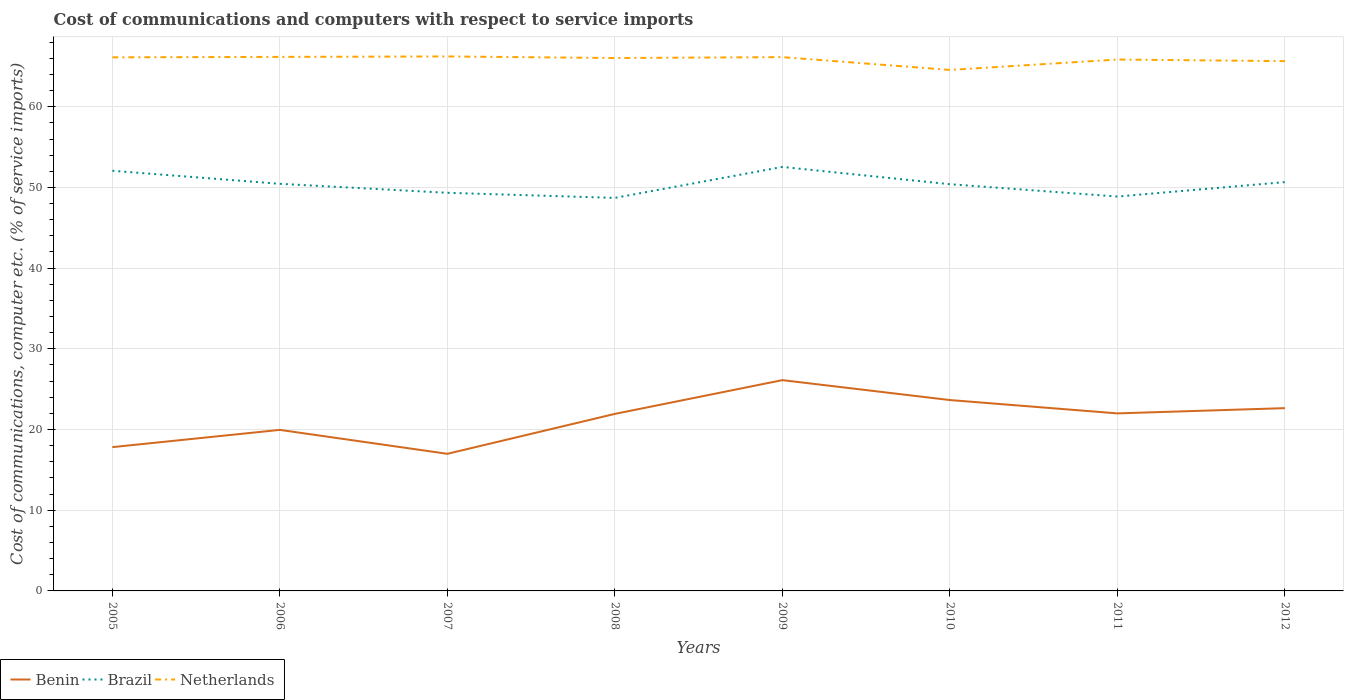Does the line corresponding to Brazil intersect with the line corresponding to Netherlands?
Offer a terse response. No. Is the number of lines equal to the number of legend labels?
Provide a succinct answer. Yes. Across all years, what is the maximum cost of communications and computers in Brazil?
Your response must be concise. 48.7. In which year was the cost of communications and computers in Netherlands maximum?
Keep it short and to the point. 2010. What is the total cost of communications and computers in Netherlands in the graph?
Give a very brief answer. 0.19. What is the difference between the highest and the second highest cost of communications and computers in Netherlands?
Keep it short and to the point. 1.67. How many lines are there?
Offer a very short reply. 3. How many years are there in the graph?
Offer a very short reply. 8. What is the difference between two consecutive major ticks on the Y-axis?
Offer a very short reply. 10. Where does the legend appear in the graph?
Offer a terse response. Bottom left. How many legend labels are there?
Your answer should be very brief. 3. How are the legend labels stacked?
Provide a succinct answer. Horizontal. What is the title of the graph?
Your answer should be very brief. Cost of communications and computers with respect to service imports. Does "Euro area" appear as one of the legend labels in the graph?
Provide a short and direct response. No. What is the label or title of the Y-axis?
Ensure brevity in your answer.  Cost of communications, computer etc. (% of service imports). What is the Cost of communications, computer etc. (% of service imports) in Benin in 2005?
Provide a short and direct response. 17.82. What is the Cost of communications, computer etc. (% of service imports) of Brazil in 2005?
Ensure brevity in your answer.  52.06. What is the Cost of communications, computer etc. (% of service imports) of Netherlands in 2005?
Give a very brief answer. 66.12. What is the Cost of communications, computer etc. (% of service imports) in Benin in 2006?
Make the answer very short. 19.96. What is the Cost of communications, computer etc. (% of service imports) in Brazil in 2006?
Offer a very short reply. 50.45. What is the Cost of communications, computer etc. (% of service imports) of Netherlands in 2006?
Provide a short and direct response. 66.18. What is the Cost of communications, computer etc. (% of service imports) of Benin in 2007?
Give a very brief answer. 16.99. What is the Cost of communications, computer etc. (% of service imports) in Brazil in 2007?
Ensure brevity in your answer.  49.34. What is the Cost of communications, computer etc. (% of service imports) in Netherlands in 2007?
Give a very brief answer. 66.23. What is the Cost of communications, computer etc. (% of service imports) of Benin in 2008?
Offer a terse response. 21.94. What is the Cost of communications, computer etc. (% of service imports) of Brazil in 2008?
Your response must be concise. 48.7. What is the Cost of communications, computer etc. (% of service imports) of Netherlands in 2008?
Offer a terse response. 66.04. What is the Cost of communications, computer etc. (% of service imports) in Benin in 2009?
Your answer should be very brief. 26.12. What is the Cost of communications, computer etc. (% of service imports) of Brazil in 2009?
Your answer should be very brief. 52.54. What is the Cost of communications, computer etc. (% of service imports) of Netherlands in 2009?
Your answer should be compact. 66.15. What is the Cost of communications, computer etc. (% of service imports) of Benin in 2010?
Provide a succinct answer. 23.65. What is the Cost of communications, computer etc. (% of service imports) in Brazil in 2010?
Offer a terse response. 50.4. What is the Cost of communications, computer etc. (% of service imports) of Netherlands in 2010?
Offer a terse response. 64.56. What is the Cost of communications, computer etc. (% of service imports) of Benin in 2011?
Your response must be concise. 22. What is the Cost of communications, computer etc. (% of service imports) of Brazil in 2011?
Your response must be concise. 48.87. What is the Cost of communications, computer etc. (% of service imports) in Netherlands in 2011?
Your response must be concise. 65.85. What is the Cost of communications, computer etc. (% of service imports) of Benin in 2012?
Offer a terse response. 22.65. What is the Cost of communications, computer etc. (% of service imports) in Brazil in 2012?
Your response must be concise. 50.66. What is the Cost of communications, computer etc. (% of service imports) of Netherlands in 2012?
Ensure brevity in your answer.  65.65. Across all years, what is the maximum Cost of communications, computer etc. (% of service imports) in Benin?
Keep it short and to the point. 26.12. Across all years, what is the maximum Cost of communications, computer etc. (% of service imports) in Brazil?
Your response must be concise. 52.54. Across all years, what is the maximum Cost of communications, computer etc. (% of service imports) in Netherlands?
Ensure brevity in your answer.  66.23. Across all years, what is the minimum Cost of communications, computer etc. (% of service imports) in Benin?
Offer a terse response. 16.99. Across all years, what is the minimum Cost of communications, computer etc. (% of service imports) of Brazil?
Offer a terse response. 48.7. Across all years, what is the minimum Cost of communications, computer etc. (% of service imports) of Netherlands?
Your response must be concise. 64.56. What is the total Cost of communications, computer etc. (% of service imports) in Benin in the graph?
Make the answer very short. 171.12. What is the total Cost of communications, computer etc. (% of service imports) in Brazil in the graph?
Your response must be concise. 403.03. What is the total Cost of communications, computer etc. (% of service imports) of Netherlands in the graph?
Provide a short and direct response. 526.77. What is the difference between the Cost of communications, computer etc. (% of service imports) in Benin in 2005 and that in 2006?
Make the answer very short. -2.14. What is the difference between the Cost of communications, computer etc. (% of service imports) in Brazil in 2005 and that in 2006?
Offer a terse response. 1.61. What is the difference between the Cost of communications, computer etc. (% of service imports) of Netherlands in 2005 and that in 2006?
Offer a very short reply. -0.05. What is the difference between the Cost of communications, computer etc. (% of service imports) of Benin in 2005 and that in 2007?
Provide a short and direct response. 0.83. What is the difference between the Cost of communications, computer etc. (% of service imports) of Brazil in 2005 and that in 2007?
Provide a succinct answer. 2.73. What is the difference between the Cost of communications, computer etc. (% of service imports) in Netherlands in 2005 and that in 2007?
Provide a succinct answer. -0.11. What is the difference between the Cost of communications, computer etc. (% of service imports) in Benin in 2005 and that in 2008?
Your answer should be compact. -4.12. What is the difference between the Cost of communications, computer etc. (% of service imports) in Brazil in 2005 and that in 2008?
Offer a very short reply. 3.36. What is the difference between the Cost of communications, computer etc. (% of service imports) of Netherlands in 2005 and that in 2008?
Offer a terse response. 0.08. What is the difference between the Cost of communications, computer etc. (% of service imports) of Benin in 2005 and that in 2009?
Offer a terse response. -8.3. What is the difference between the Cost of communications, computer etc. (% of service imports) in Brazil in 2005 and that in 2009?
Your answer should be compact. -0.48. What is the difference between the Cost of communications, computer etc. (% of service imports) of Netherlands in 2005 and that in 2009?
Make the answer very short. -0.03. What is the difference between the Cost of communications, computer etc. (% of service imports) of Benin in 2005 and that in 2010?
Your response must be concise. -5.84. What is the difference between the Cost of communications, computer etc. (% of service imports) of Brazil in 2005 and that in 2010?
Your answer should be compact. 1.66. What is the difference between the Cost of communications, computer etc. (% of service imports) in Netherlands in 2005 and that in 2010?
Your answer should be very brief. 1.56. What is the difference between the Cost of communications, computer etc. (% of service imports) of Benin in 2005 and that in 2011?
Make the answer very short. -4.18. What is the difference between the Cost of communications, computer etc. (% of service imports) of Brazil in 2005 and that in 2011?
Your answer should be compact. 3.19. What is the difference between the Cost of communications, computer etc. (% of service imports) in Netherlands in 2005 and that in 2011?
Offer a very short reply. 0.27. What is the difference between the Cost of communications, computer etc. (% of service imports) of Benin in 2005 and that in 2012?
Your response must be concise. -4.83. What is the difference between the Cost of communications, computer etc. (% of service imports) of Brazil in 2005 and that in 2012?
Offer a terse response. 1.4. What is the difference between the Cost of communications, computer etc. (% of service imports) of Netherlands in 2005 and that in 2012?
Make the answer very short. 0.47. What is the difference between the Cost of communications, computer etc. (% of service imports) of Benin in 2006 and that in 2007?
Make the answer very short. 2.97. What is the difference between the Cost of communications, computer etc. (% of service imports) of Brazil in 2006 and that in 2007?
Your answer should be compact. 1.11. What is the difference between the Cost of communications, computer etc. (% of service imports) of Netherlands in 2006 and that in 2007?
Make the answer very short. -0.06. What is the difference between the Cost of communications, computer etc. (% of service imports) in Benin in 2006 and that in 2008?
Offer a very short reply. -1.98. What is the difference between the Cost of communications, computer etc. (% of service imports) in Brazil in 2006 and that in 2008?
Your answer should be compact. 1.75. What is the difference between the Cost of communications, computer etc. (% of service imports) of Netherlands in 2006 and that in 2008?
Offer a terse response. 0.14. What is the difference between the Cost of communications, computer etc. (% of service imports) of Benin in 2006 and that in 2009?
Provide a succinct answer. -6.17. What is the difference between the Cost of communications, computer etc. (% of service imports) of Brazil in 2006 and that in 2009?
Offer a very short reply. -2.09. What is the difference between the Cost of communications, computer etc. (% of service imports) in Netherlands in 2006 and that in 2009?
Ensure brevity in your answer.  0.03. What is the difference between the Cost of communications, computer etc. (% of service imports) of Benin in 2006 and that in 2010?
Your answer should be compact. -3.7. What is the difference between the Cost of communications, computer etc. (% of service imports) in Brazil in 2006 and that in 2010?
Offer a very short reply. 0.05. What is the difference between the Cost of communications, computer etc. (% of service imports) in Netherlands in 2006 and that in 2010?
Keep it short and to the point. 1.62. What is the difference between the Cost of communications, computer etc. (% of service imports) of Benin in 2006 and that in 2011?
Your answer should be compact. -2.04. What is the difference between the Cost of communications, computer etc. (% of service imports) of Brazil in 2006 and that in 2011?
Offer a very short reply. 1.58. What is the difference between the Cost of communications, computer etc. (% of service imports) in Netherlands in 2006 and that in 2011?
Your response must be concise. 0.33. What is the difference between the Cost of communications, computer etc. (% of service imports) of Benin in 2006 and that in 2012?
Your response must be concise. -2.7. What is the difference between the Cost of communications, computer etc. (% of service imports) in Brazil in 2006 and that in 2012?
Offer a terse response. -0.21. What is the difference between the Cost of communications, computer etc. (% of service imports) of Netherlands in 2006 and that in 2012?
Your answer should be very brief. 0.53. What is the difference between the Cost of communications, computer etc. (% of service imports) in Benin in 2007 and that in 2008?
Provide a succinct answer. -4.95. What is the difference between the Cost of communications, computer etc. (% of service imports) in Brazil in 2007 and that in 2008?
Give a very brief answer. 0.63. What is the difference between the Cost of communications, computer etc. (% of service imports) of Netherlands in 2007 and that in 2008?
Make the answer very short. 0.2. What is the difference between the Cost of communications, computer etc. (% of service imports) in Benin in 2007 and that in 2009?
Offer a very short reply. -9.13. What is the difference between the Cost of communications, computer etc. (% of service imports) in Brazil in 2007 and that in 2009?
Your answer should be compact. -3.21. What is the difference between the Cost of communications, computer etc. (% of service imports) of Netherlands in 2007 and that in 2009?
Your answer should be compact. 0.09. What is the difference between the Cost of communications, computer etc. (% of service imports) of Benin in 2007 and that in 2010?
Provide a succinct answer. -6.66. What is the difference between the Cost of communications, computer etc. (% of service imports) of Brazil in 2007 and that in 2010?
Provide a succinct answer. -1.06. What is the difference between the Cost of communications, computer etc. (% of service imports) of Netherlands in 2007 and that in 2010?
Make the answer very short. 1.67. What is the difference between the Cost of communications, computer etc. (% of service imports) in Benin in 2007 and that in 2011?
Offer a terse response. -5.01. What is the difference between the Cost of communications, computer etc. (% of service imports) of Brazil in 2007 and that in 2011?
Offer a very short reply. 0.46. What is the difference between the Cost of communications, computer etc. (% of service imports) in Netherlands in 2007 and that in 2011?
Give a very brief answer. 0.38. What is the difference between the Cost of communications, computer etc. (% of service imports) in Benin in 2007 and that in 2012?
Provide a short and direct response. -5.66. What is the difference between the Cost of communications, computer etc. (% of service imports) of Brazil in 2007 and that in 2012?
Provide a succinct answer. -1.33. What is the difference between the Cost of communications, computer etc. (% of service imports) in Netherlands in 2007 and that in 2012?
Offer a very short reply. 0.58. What is the difference between the Cost of communications, computer etc. (% of service imports) in Benin in 2008 and that in 2009?
Provide a short and direct response. -4.18. What is the difference between the Cost of communications, computer etc. (% of service imports) of Brazil in 2008 and that in 2009?
Keep it short and to the point. -3.84. What is the difference between the Cost of communications, computer etc. (% of service imports) in Netherlands in 2008 and that in 2009?
Your answer should be compact. -0.11. What is the difference between the Cost of communications, computer etc. (% of service imports) of Benin in 2008 and that in 2010?
Provide a short and direct response. -1.72. What is the difference between the Cost of communications, computer etc. (% of service imports) in Brazil in 2008 and that in 2010?
Ensure brevity in your answer.  -1.7. What is the difference between the Cost of communications, computer etc. (% of service imports) in Netherlands in 2008 and that in 2010?
Your answer should be compact. 1.48. What is the difference between the Cost of communications, computer etc. (% of service imports) in Benin in 2008 and that in 2011?
Your answer should be very brief. -0.06. What is the difference between the Cost of communications, computer etc. (% of service imports) in Brazil in 2008 and that in 2011?
Give a very brief answer. -0.17. What is the difference between the Cost of communications, computer etc. (% of service imports) in Netherlands in 2008 and that in 2011?
Provide a succinct answer. 0.19. What is the difference between the Cost of communications, computer etc. (% of service imports) of Benin in 2008 and that in 2012?
Your answer should be very brief. -0.71. What is the difference between the Cost of communications, computer etc. (% of service imports) of Brazil in 2008 and that in 2012?
Your response must be concise. -1.96. What is the difference between the Cost of communications, computer etc. (% of service imports) of Netherlands in 2008 and that in 2012?
Provide a short and direct response. 0.39. What is the difference between the Cost of communications, computer etc. (% of service imports) of Benin in 2009 and that in 2010?
Your response must be concise. 2.47. What is the difference between the Cost of communications, computer etc. (% of service imports) in Brazil in 2009 and that in 2010?
Your response must be concise. 2.14. What is the difference between the Cost of communications, computer etc. (% of service imports) in Netherlands in 2009 and that in 2010?
Give a very brief answer. 1.59. What is the difference between the Cost of communications, computer etc. (% of service imports) in Benin in 2009 and that in 2011?
Make the answer very short. 4.12. What is the difference between the Cost of communications, computer etc. (% of service imports) of Brazil in 2009 and that in 2011?
Provide a short and direct response. 3.67. What is the difference between the Cost of communications, computer etc. (% of service imports) of Netherlands in 2009 and that in 2011?
Provide a short and direct response. 0.3. What is the difference between the Cost of communications, computer etc. (% of service imports) of Benin in 2009 and that in 2012?
Your response must be concise. 3.47. What is the difference between the Cost of communications, computer etc. (% of service imports) of Brazil in 2009 and that in 2012?
Offer a terse response. 1.88. What is the difference between the Cost of communications, computer etc. (% of service imports) in Netherlands in 2009 and that in 2012?
Make the answer very short. 0.5. What is the difference between the Cost of communications, computer etc. (% of service imports) of Benin in 2010 and that in 2011?
Make the answer very short. 1.65. What is the difference between the Cost of communications, computer etc. (% of service imports) of Brazil in 2010 and that in 2011?
Provide a short and direct response. 1.53. What is the difference between the Cost of communications, computer etc. (% of service imports) of Netherlands in 2010 and that in 2011?
Provide a succinct answer. -1.29. What is the difference between the Cost of communications, computer etc. (% of service imports) of Brazil in 2010 and that in 2012?
Your answer should be compact. -0.26. What is the difference between the Cost of communications, computer etc. (% of service imports) of Netherlands in 2010 and that in 2012?
Provide a succinct answer. -1.09. What is the difference between the Cost of communications, computer etc. (% of service imports) of Benin in 2011 and that in 2012?
Ensure brevity in your answer.  -0.65. What is the difference between the Cost of communications, computer etc. (% of service imports) in Brazil in 2011 and that in 2012?
Offer a terse response. -1.79. What is the difference between the Cost of communications, computer etc. (% of service imports) in Netherlands in 2011 and that in 2012?
Your answer should be very brief. 0.2. What is the difference between the Cost of communications, computer etc. (% of service imports) in Benin in 2005 and the Cost of communications, computer etc. (% of service imports) in Brazil in 2006?
Your answer should be compact. -32.63. What is the difference between the Cost of communications, computer etc. (% of service imports) of Benin in 2005 and the Cost of communications, computer etc. (% of service imports) of Netherlands in 2006?
Ensure brevity in your answer.  -48.36. What is the difference between the Cost of communications, computer etc. (% of service imports) of Brazil in 2005 and the Cost of communications, computer etc. (% of service imports) of Netherlands in 2006?
Offer a very short reply. -14.11. What is the difference between the Cost of communications, computer etc. (% of service imports) in Benin in 2005 and the Cost of communications, computer etc. (% of service imports) in Brazil in 2007?
Make the answer very short. -31.52. What is the difference between the Cost of communications, computer etc. (% of service imports) in Benin in 2005 and the Cost of communications, computer etc. (% of service imports) in Netherlands in 2007?
Ensure brevity in your answer.  -48.41. What is the difference between the Cost of communications, computer etc. (% of service imports) of Brazil in 2005 and the Cost of communications, computer etc. (% of service imports) of Netherlands in 2007?
Provide a succinct answer. -14.17. What is the difference between the Cost of communications, computer etc. (% of service imports) in Benin in 2005 and the Cost of communications, computer etc. (% of service imports) in Brazil in 2008?
Provide a short and direct response. -30.89. What is the difference between the Cost of communications, computer etc. (% of service imports) in Benin in 2005 and the Cost of communications, computer etc. (% of service imports) in Netherlands in 2008?
Ensure brevity in your answer.  -48.22. What is the difference between the Cost of communications, computer etc. (% of service imports) in Brazil in 2005 and the Cost of communications, computer etc. (% of service imports) in Netherlands in 2008?
Offer a very short reply. -13.97. What is the difference between the Cost of communications, computer etc. (% of service imports) of Benin in 2005 and the Cost of communications, computer etc. (% of service imports) of Brazil in 2009?
Offer a very short reply. -34.72. What is the difference between the Cost of communications, computer etc. (% of service imports) in Benin in 2005 and the Cost of communications, computer etc. (% of service imports) in Netherlands in 2009?
Your answer should be compact. -48.33. What is the difference between the Cost of communications, computer etc. (% of service imports) in Brazil in 2005 and the Cost of communications, computer etc. (% of service imports) in Netherlands in 2009?
Keep it short and to the point. -14.08. What is the difference between the Cost of communications, computer etc. (% of service imports) of Benin in 2005 and the Cost of communications, computer etc. (% of service imports) of Brazil in 2010?
Keep it short and to the point. -32.58. What is the difference between the Cost of communications, computer etc. (% of service imports) of Benin in 2005 and the Cost of communications, computer etc. (% of service imports) of Netherlands in 2010?
Offer a terse response. -46.74. What is the difference between the Cost of communications, computer etc. (% of service imports) in Brazil in 2005 and the Cost of communications, computer etc. (% of service imports) in Netherlands in 2010?
Your answer should be very brief. -12.5. What is the difference between the Cost of communications, computer etc. (% of service imports) in Benin in 2005 and the Cost of communications, computer etc. (% of service imports) in Brazil in 2011?
Your answer should be very brief. -31.05. What is the difference between the Cost of communications, computer etc. (% of service imports) in Benin in 2005 and the Cost of communications, computer etc. (% of service imports) in Netherlands in 2011?
Your response must be concise. -48.03. What is the difference between the Cost of communications, computer etc. (% of service imports) of Brazil in 2005 and the Cost of communications, computer etc. (% of service imports) of Netherlands in 2011?
Your answer should be compact. -13.78. What is the difference between the Cost of communications, computer etc. (% of service imports) of Benin in 2005 and the Cost of communications, computer etc. (% of service imports) of Brazil in 2012?
Make the answer very short. -32.84. What is the difference between the Cost of communications, computer etc. (% of service imports) in Benin in 2005 and the Cost of communications, computer etc. (% of service imports) in Netherlands in 2012?
Give a very brief answer. -47.83. What is the difference between the Cost of communications, computer etc. (% of service imports) in Brazil in 2005 and the Cost of communications, computer etc. (% of service imports) in Netherlands in 2012?
Keep it short and to the point. -13.59. What is the difference between the Cost of communications, computer etc. (% of service imports) of Benin in 2006 and the Cost of communications, computer etc. (% of service imports) of Brazil in 2007?
Your answer should be compact. -29.38. What is the difference between the Cost of communications, computer etc. (% of service imports) of Benin in 2006 and the Cost of communications, computer etc. (% of service imports) of Netherlands in 2007?
Offer a terse response. -46.28. What is the difference between the Cost of communications, computer etc. (% of service imports) in Brazil in 2006 and the Cost of communications, computer etc. (% of service imports) in Netherlands in 2007?
Provide a short and direct response. -15.78. What is the difference between the Cost of communications, computer etc. (% of service imports) of Benin in 2006 and the Cost of communications, computer etc. (% of service imports) of Brazil in 2008?
Provide a succinct answer. -28.75. What is the difference between the Cost of communications, computer etc. (% of service imports) of Benin in 2006 and the Cost of communications, computer etc. (% of service imports) of Netherlands in 2008?
Provide a short and direct response. -46.08. What is the difference between the Cost of communications, computer etc. (% of service imports) of Brazil in 2006 and the Cost of communications, computer etc. (% of service imports) of Netherlands in 2008?
Provide a short and direct response. -15.59. What is the difference between the Cost of communications, computer etc. (% of service imports) in Benin in 2006 and the Cost of communications, computer etc. (% of service imports) in Brazil in 2009?
Ensure brevity in your answer.  -32.59. What is the difference between the Cost of communications, computer etc. (% of service imports) of Benin in 2006 and the Cost of communications, computer etc. (% of service imports) of Netherlands in 2009?
Offer a terse response. -46.19. What is the difference between the Cost of communications, computer etc. (% of service imports) in Brazil in 2006 and the Cost of communications, computer etc. (% of service imports) in Netherlands in 2009?
Your answer should be compact. -15.7. What is the difference between the Cost of communications, computer etc. (% of service imports) of Benin in 2006 and the Cost of communications, computer etc. (% of service imports) of Brazil in 2010?
Your answer should be very brief. -30.44. What is the difference between the Cost of communications, computer etc. (% of service imports) in Benin in 2006 and the Cost of communications, computer etc. (% of service imports) in Netherlands in 2010?
Provide a succinct answer. -44.6. What is the difference between the Cost of communications, computer etc. (% of service imports) in Brazil in 2006 and the Cost of communications, computer etc. (% of service imports) in Netherlands in 2010?
Provide a succinct answer. -14.11. What is the difference between the Cost of communications, computer etc. (% of service imports) of Benin in 2006 and the Cost of communications, computer etc. (% of service imports) of Brazil in 2011?
Keep it short and to the point. -28.92. What is the difference between the Cost of communications, computer etc. (% of service imports) in Benin in 2006 and the Cost of communications, computer etc. (% of service imports) in Netherlands in 2011?
Offer a very short reply. -45.89. What is the difference between the Cost of communications, computer etc. (% of service imports) in Brazil in 2006 and the Cost of communications, computer etc. (% of service imports) in Netherlands in 2011?
Make the answer very short. -15.4. What is the difference between the Cost of communications, computer etc. (% of service imports) of Benin in 2006 and the Cost of communications, computer etc. (% of service imports) of Brazil in 2012?
Offer a very short reply. -30.71. What is the difference between the Cost of communications, computer etc. (% of service imports) of Benin in 2006 and the Cost of communications, computer etc. (% of service imports) of Netherlands in 2012?
Provide a succinct answer. -45.69. What is the difference between the Cost of communications, computer etc. (% of service imports) of Brazil in 2006 and the Cost of communications, computer etc. (% of service imports) of Netherlands in 2012?
Offer a terse response. -15.2. What is the difference between the Cost of communications, computer etc. (% of service imports) in Benin in 2007 and the Cost of communications, computer etc. (% of service imports) in Brazil in 2008?
Offer a terse response. -31.71. What is the difference between the Cost of communications, computer etc. (% of service imports) of Benin in 2007 and the Cost of communications, computer etc. (% of service imports) of Netherlands in 2008?
Your response must be concise. -49.05. What is the difference between the Cost of communications, computer etc. (% of service imports) in Brazil in 2007 and the Cost of communications, computer etc. (% of service imports) in Netherlands in 2008?
Keep it short and to the point. -16.7. What is the difference between the Cost of communications, computer etc. (% of service imports) of Benin in 2007 and the Cost of communications, computer etc. (% of service imports) of Brazil in 2009?
Give a very brief answer. -35.55. What is the difference between the Cost of communications, computer etc. (% of service imports) of Benin in 2007 and the Cost of communications, computer etc. (% of service imports) of Netherlands in 2009?
Provide a succinct answer. -49.16. What is the difference between the Cost of communications, computer etc. (% of service imports) in Brazil in 2007 and the Cost of communications, computer etc. (% of service imports) in Netherlands in 2009?
Keep it short and to the point. -16.81. What is the difference between the Cost of communications, computer etc. (% of service imports) in Benin in 2007 and the Cost of communications, computer etc. (% of service imports) in Brazil in 2010?
Provide a succinct answer. -33.41. What is the difference between the Cost of communications, computer etc. (% of service imports) in Benin in 2007 and the Cost of communications, computer etc. (% of service imports) in Netherlands in 2010?
Keep it short and to the point. -47.57. What is the difference between the Cost of communications, computer etc. (% of service imports) of Brazil in 2007 and the Cost of communications, computer etc. (% of service imports) of Netherlands in 2010?
Give a very brief answer. -15.22. What is the difference between the Cost of communications, computer etc. (% of service imports) of Benin in 2007 and the Cost of communications, computer etc. (% of service imports) of Brazil in 2011?
Offer a terse response. -31.88. What is the difference between the Cost of communications, computer etc. (% of service imports) in Benin in 2007 and the Cost of communications, computer etc. (% of service imports) in Netherlands in 2011?
Your answer should be compact. -48.86. What is the difference between the Cost of communications, computer etc. (% of service imports) in Brazil in 2007 and the Cost of communications, computer etc. (% of service imports) in Netherlands in 2011?
Offer a very short reply. -16.51. What is the difference between the Cost of communications, computer etc. (% of service imports) in Benin in 2007 and the Cost of communications, computer etc. (% of service imports) in Brazil in 2012?
Provide a succinct answer. -33.67. What is the difference between the Cost of communications, computer etc. (% of service imports) in Benin in 2007 and the Cost of communications, computer etc. (% of service imports) in Netherlands in 2012?
Give a very brief answer. -48.66. What is the difference between the Cost of communications, computer etc. (% of service imports) of Brazil in 2007 and the Cost of communications, computer etc. (% of service imports) of Netherlands in 2012?
Offer a terse response. -16.31. What is the difference between the Cost of communications, computer etc. (% of service imports) of Benin in 2008 and the Cost of communications, computer etc. (% of service imports) of Brazil in 2009?
Your response must be concise. -30.61. What is the difference between the Cost of communications, computer etc. (% of service imports) in Benin in 2008 and the Cost of communications, computer etc. (% of service imports) in Netherlands in 2009?
Your response must be concise. -44.21. What is the difference between the Cost of communications, computer etc. (% of service imports) in Brazil in 2008 and the Cost of communications, computer etc. (% of service imports) in Netherlands in 2009?
Keep it short and to the point. -17.44. What is the difference between the Cost of communications, computer etc. (% of service imports) of Benin in 2008 and the Cost of communications, computer etc. (% of service imports) of Brazil in 2010?
Offer a terse response. -28.46. What is the difference between the Cost of communications, computer etc. (% of service imports) of Benin in 2008 and the Cost of communications, computer etc. (% of service imports) of Netherlands in 2010?
Your answer should be very brief. -42.62. What is the difference between the Cost of communications, computer etc. (% of service imports) in Brazil in 2008 and the Cost of communications, computer etc. (% of service imports) in Netherlands in 2010?
Provide a short and direct response. -15.86. What is the difference between the Cost of communications, computer etc. (% of service imports) of Benin in 2008 and the Cost of communications, computer etc. (% of service imports) of Brazil in 2011?
Make the answer very short. -26.93. What is the difference between the Cost of communications, computer etc. (% of service imports) in Benin in 2008 and the Cost of communications, computer etc. (% of service imports) in Netherlands in 2011?
Offer a very short reply. -43.91. What is the difference between the Cost of communications, computer etc. (% of service imports) of Brazil in 2008 and the Cost of communications, computer etc. (% of service imports) of Netherlands in 2011?
Your answer should be very brief. -17.14. What is the difference between the Cost of communications, computer etc. (% of service imports) of Benin in 2008 and the Cost of communications, computer etc. (% of service imports) of Brazil in 2012?
Your answer should be very brief. -28.72. What is the difference between the Cost of communications, computer etc. (% of service imports) in Benin in 2008 and the Cost of communications, computer etc. (% of service imports) in Netherlands in 2012?
Keep it short and to the point. -43.71. What is the difference between the Cost of communications, computer etc. (% of service imports) of Brazil in 2008 and the Cost of communications, computer etc. (% of service imports) of Netherlands in 2012?
Provide a succinct answer. -16.95. What is the difference between the Cost of communications, computer etc. (% of service imports) in Benin in 2009 and the Cost of communications, computer etc. (% of service imports) in Brazil in 2010?
Ensure brevity in your answer.  -24.28. What is the difference between the Cost of communications, computer etc. (% of service imports) in Benin in 2009 and the Cost of communications, computer etc. (% of service imports) in Netherlands in 2010?
Offer a terse response. -38.44. What is the difference between the Cost of communications, computer etc. (% of service imports) in Brazil in 2009 and the Cost of communications, computer etc. (% of service imports) in Netherlands in 2010?
Give a very brief answer. -12.02. What is the difference between the Cost of communications, computer etc. (% of service imports) in Benin in 2009 and the Cost of communications, computer etc. (% of service imports) in Brazil in 2011?
Provide a succinct answer. -22.75. What is the difference between the Cost of communications, computer etc. (% of service imports) of Benin in 2009 and the Cost of communications, computer etc. (% of service imports) of Netherlands in 2011?
Your answer should be very brief. -39.73. What is the difference between the Cost of communications, computer etc. (% of service imports) of Brazil in 2009 and the Cost of communications, computer etc. (% of service imports) of Netherlands in 2011?
Offer a very short reply. -13.31. What is the difference between the Cost of communications, computer etc. (% of service imports) in Benin in 2009 and the Cost of communications, computer etc. (% of service imports) in Brazil in 2012?
Ensure brevity in your answer.  -24.54. What is the difference between the Cost of communications, computer etc. (% of service imports) in Benin in 2009 and the Cost of communications, computer etc. (% of service imports) in Netherlands in 2012?
Make the answer very short. -39.53. What is the difference between the Cost of communications, computer etc. (% of service imports) of Brazil in 2009 and the Cost of communications, computer etc. (% of service imports) of Netherlands in 2012?
Give a very brief answer. -13.11. What is the difference between the Cost of communications, computer etc. (% of service imports) of Benin in 2010 and the Cost of communications, computer etc. (% of service imports) of Brazil in 2011?
Ensure brevity in your answer.  -25.22. What is the difference between the Cost of communications, computer etc. (% of service imports) of Benin in 2010 and the Cost of communications, computer etc. (% of service imports) of Netherlands in 2011?
Your answer should be compact. -42.2. What is the difference between the Cost of communications, computer etc. (% of service imports) in Brazil in 2010 and the Cost of communications, computer etc. (% of service imports) in Netherlands in 2011?
Make the answer very short. -15.45. What is the difference between the Cost of communications, computer etc. (% of service imports) of Benin in 2010 and the Cost of communications, computer etc. (% of service imports) of Brazil in 2012?
Provide a short and direct response. -27.01. What is the difference between the Cost of communications, computer etc. (% of service imports) of Benin in 2010 and the Cost of communications, computer etc. (% of service imports) of Netherlands in 2012?
Make the answer very short. -42. What is the difference between the Cost of communications, computer etc. (% of service imports) of Brazil in 2010 and the Cost of communications, computer etc. (% of service imports) of Netherlands in 2012?
Keep it short and to the point. -15.25. What is the difference between the Cost of communications, computer etc. (% of service imports) in Benin in 2011 and the Cost of communications, computer etc. (% of service imports) in Brazil in 2012?
Your response must be concise. -28.66. What is the difference between the Cost of communications, computer etc. (% of service imports) in Benin in 2011 and the Cost of communications, computer etc. (% of service imports) in Netherlands in 2012?
Your answer should be compact. -43.65. What is the difference between the Cost of communications, computer etc. (% of service imports) of Brazil in 2011 and the Cost of communications, computer etc. (% of service imports) of Netherlands in 2012?
Keep it short and to the point. -16.78. What is the average Cost of communications, computer etc. (% of service imports) of Benin per year?
Ensure brevity in your answer.  21.39. What is the average Cost of communications, computer etc. (% of service imports) of Brazil per year?
Your answer should be compact. 50.38. What is the average Cost of communications, computer etc. (% of service imports) in Netherlands per year?
Offer a very short reply. 65.85. In the year 2005, what is the difference between the Cost of communications, computer etc. (% of service imports) in Benin and Cost of communications, computer etc. (% of service imports) in Brazil?
Provide a short and direct response. -34.25. In the year 2005, what is the difference between the Cost of communications, computer etc. (% of service imports) in Benin and Cost of communications, computer etc. (% of service imports) in Netherlands?
Offer a terse response. -48.3. In the year 2005, what is the difference between the Cost of communications, computer etc. (% of service imports) in Brazil and Cost of communications, computer etc. (% of service imports) in Netherlands?
Ensure brevity in your answer.  -14.06. In the year 2006, what is the difference between the Cost of communications, computer etc. (% of service imports) in Benin and Cost of communications, computer etc. (% of service imports) in Brazil?
Make the answer very short. -30.49. In the year 2006, what is the difference between the Cost of communications, computer etc. (% of service imports) in Benin and Cost of communications, computer etc. (% of service imports) in Netherlands?
Make the answer very short. -46.22. In the year 2006, what is the difference between the Cost of communications, computer etc. (% of service imports) of Brazil and Cost of communications, computer etc. (% of service imports) of Netherlands?
Ensure brevity in your answer.  -15.73. In the year 2007, what is the difference between the Cost of communications, computer etc. (% of service imports) in Benin and Cost of communications, computer etc. (% of service imports) in Brazil?
Your response must be concise. -32.34. In the year 2007, what is the difference between the Cost of communications, computer etc. (% of service imports) in Benin and Cost of communications, computer etc. (% of service imports) in Netherlands?
Provide a succinct answer. -49.24. In the year 2007, what is the difference between the Cost of communications, computer etc. (% of service imports) in Brazil and Cost of communications, computer etc. (% of service imports) in Netherlands?
Offer a very short reply. -16.9. In the year 2008, what is the difference between the Cost of communications, computer etc. (% of service imports) of Benin and Cost of communications, computer etc. (% of service imports) of Brazil?
Offer a very short reply. -26.77. In the year 2008, what is the difference between the Cost of communications, computer etc. (% of service imports) in Benin and Cost of communications, computer etc. (% of service imports) in Netherlands?
Offer a very short reply. -44.1. In the year 2008, what is the difference between the Cost of communications, computer etc. (% of service imports) of Brazil and Cost of communications, computer etc. (% of service imports) of Netherlands?
Make the answer very short. -17.33. In the year 2009, what is the difference between the Cost of communications, computer etc. (% of service imports) in Benin and Cost of communications, computer etc. (% of service imports) in Brazil?
Offer a very short reply. -26.42. In the year 2009, what is the difference between the Cost of communications, computer etc. (% of service imports) of Benin and Cost of communications, computer etc. (% of service imports) of Netherlands?
Give a very brief answer. -40.03. In the year 2009, what is the difference between the Cost of communications, computer etc. (% of service imports) in Brazil and Cost of communications, computer etc. (% of service imports) in Netherlands?
Offer a very short reply. -13.61. In the year 2010, what is the difference between the Cost of communications, computer etc. (% of service imports) of Benin and Cost of communications, computer etc. (% of service imports) of Brazil?
Your answer should be compact. -26.75. In the year 2010, what is the difference between the Cost of communications, computer etc. (% of service imports) of Benin and Cost of communications, computer etc. (% of service imports) of Netherlands?
Give a very brief answer. -40.91. In the year 2010, what is the difference between the Cost of communications, computer etc. (% of service imports) in Brazil and Cost of communications, computer etc. (% of service imports) in Netherlands?
Keep it short and to the point. -14.16. In the year 2011, what is the difference between the Cost of communications, computer etc. (% of service imports) in Benin and Cost of communications, computer etc. (% of service imports) in Brazil?
Your response must be concise. -26.87. In the year 2011, what is the difference between the Cost of communications, computer etc. (% of service imports) of Benin and Cost of communications, computer etc. (% of service imports) of Netherlands?
Ensure brevity in your answer.  -43.85. In the year 2011, what is the difference between the Cost of communications, computer etc. (% of service imports) of Brazil and Cost of communications, computer etc. (% of service imports) of Netherlands?
Make the answer very short. -16.98. In the year 2012, what is the difference between the Cost of communications, computer etc. (% of service imports) of Benin and Cost of communications, computer etc. (% of service imports) of Brazil?
Ensure brevity in your answer.  -28.01. In the year 2012, what is the difference between the Cost of communications, computer etc. (% of service imports) in Benin and Cost of communications, computer etc. (% of service imports) in Netherlands?
Give a very brief answer. -43. In the year 2012, what is the difference between the Cost of communications, computer etc. (% of service imports) in Brazil and Cost of communications, computer etc. (% of service imports) in Netherlands?
Offer a very short reply. -14.99. What is the ratio of the Cost of communications, computer etc. (% of service imports) in Benin in 2005 to that in 2006?
Keep it short and to the point. 0.89. What is the ratio of the Cost of communications, computer etc. (% of service imports) in Brazil in 2005 to that in 2006?
Provide a short and direct response. 1.03. What is the ratio of the Cost of communications, computer etc. (% of service imports) of Netherlands in 2005 to that in 2006?
Offer a terse response. 1. What is the ratio of the Cost of communications, computer etc. (% of service imports) of Benin in 2005 to that in 2007?
Your answer should be very brief. 1.05. What is the ratio of the Cost of communications, computer etc. (% of service imports) of Brazil in 2005 to that in 2007?
Provide a succinct answer. 1.06. What is the ratio of the Cost of communications, computer etc. (% of service imports) in Benin in 2005 to that in 2008?
Ensure brevity in your answer.  0.81. What is the ratio of the Cost of communications, computer etc. (% of service imports) of Brazil in 2005 to that in 2008?
Give a very brief answer. 1.07. What is the ratio of the Cost of communications, computer etc. (% of service imports) in Netherlands in 2005 to that in 2008?
Your answer should be compact. 1. What is the ratio of the Cost of communications, computer etc. (% of service imports) in Benin in 2005 to that in 2009?
Your answer should be very brief. 0.68. What is the ratio of the Cost of communications, computer etc. (% of service imports) of Brazil in 2005 to that in 2009?
Your answer should be very brief. 0.99. What is the ratio of the Cost of communications, computer etc. (% of service imports) of Benin in 2005 to that in 2010?
Provide a succinct answer. 0.75. What is the ratio of the Cost of communications, computer etc. (% of service imports) of Brazil in 2005 to that in 2010?
Make the answer very short. 1.03. What is the ratio of the Cost of communications, computer etc. (% of service imports) of Netherlands in 2005 to that in 2010?
Offer a very short reply. 1.02. What is the ratio of the Cost of communications, computer etc. (% of service imports) of Benin in 2005 to that in 2011?
Provide a short and direct response. 0.81. What is the ratio of the Cost of communications, computer etc. (% of service imports) of Brazil in 2005 to that in 2011?
Your response must be concise. 1.07. What is the ratio of the Cost of communications, computer etc. (% of service imports) in Benin in 2005 to that in 2012?
Your response must be concise. 0.79. What is the ratio of the Cost of communications, computer etc. (% of service imports) in Brazil in 2005 to that in 2012?
Provide a short and direct response. 1.03. What is the ratio of the Cost of communications, computer etc. (% of service imports) in Benin in 2006 to that in 2007?
Provide a short and direct response. 1.17. What is the ratio of the Cost of communications, computer etc. (% of service imports) of Brazil in 2006 to that in 2007?
Give a very brief answer. 1.02. What is the ratio of the Cost of communications, computer etc. (% of service imports) of Benin in 2006 to that in 2008?
Give a very brief answer. 0.91. What is the ratio of the Cost of communications, computer etc. (% of service imports) in Brazil in 2006 to that in 2008?
Provide a short and direct response. 1.04. What is the ratio of the Cost of communications, computer etc. (% of service imports) in Netherlands in 2006 to that in 2008?
Keep it short and to the point. 1. What is the ratio of the Cost of communications, computer etc. (% of service imports) in Benin in 2006 to that in 2009?
Provide a short and direct response. 0.76. What is the ratio of the Cost of communications, computer etc. (% of service imports) in Brazil in 2006 to that in 2009?
Ensure brevity in your answer.  0.96. What is the ratio of the Cost of communications, computer etc. (% of service imports) of Netherlands in 2006 to that in 2009?
Keep it short and to the point. 1. What is the ratio of the Cost of communications, computer etc. (% of service imports) in Benin in 2006 to that in 2010?
Make the answer very short. 0.84. What is the ratio of the Cost of communications, computer etc. (% of service imports) in Netherlands in 2006 to that in 2010?
Keep it short and to the point. 1.02. What is the ratio of the Cost of communications, computer etc. (% of service imports) of Benin in 2006 to that in 2011?
Your response must be concise. 0.91. What is the ratio of the Cost of communications, computer etc. (% of service imports) of Brazil in 2006 to that in 2011?
Ensure brevity in your answer.  1.03. What is the ratio of the Cost of communications, computer etc. (% of service imports) in Netherlands in 2006 to that in 2011?
Offer a very short reply. 1. What is the ratio of the Cost of communications, computer etc. (% of service imports) of Benin in 2006 to that in 2012?
Offer a terse response. 0.88. What is the ratio of the Cost of communications, computer etc. (% of service imports) in Brazil in 2006 to that in 2012?
Keep it short and to the point. 1. What is the ratio of the Cost of communications, computer etc. (% of service imports) in Netherlands in 2006 to that in 2012?
Your response must be concise. 1.01. What is the ratio of the Cost of communications, computer etc. (% of service imports) of Benin in 2007 to that in 2008?
Your answer should be compact. 0.77. What is the ratio of the Cost of communications, computer etc. (% of service imports) of Brazil in 2007 to that in 2008?
Give a very brief answer. 1.01. What is the ratio of the Cost of communications, computer etc. (% of service imports) of Benin in 2007 to that in 2009?
Offer a very short reply. 0.65. What is the ratio of the Cost of communications, computer etc. (% of service imports) in Brazil in 2007 to that in 2009?
Your answer should be compact. 0.94. What is the ratio of the Cost of communications, computer etc. (% of service imports) in Benin in 2007 to that in 2010?
Provide a succinct answer. 0.72. What is the ratio of the Cost of communications, computer etc. (% of service imports) of Brazil in 2007 to that in 2010?
Provide a short and direct response. 0.98. What is the ratio of the Cost of communications, computer etc. (% of service imports) of Netherlands in 2007 to that in 2010?
Offer a terse response. 1.03. What is the ratio of the Cost of communications, computer etc. (% of service imports) in Benin in 2007 to that in 2011?
Offer a very short reply. 0.77. What is the ratio of the Cost of communications, computer etc. (% of service imports) in Brazil in 2007 to that in 2011?
Your response must be concise. 1.01. What is the ratio of the Cost of communications, computer etc. (% of service imports) of Benin in 2007 to that in 2012?
Provide a short and direct response. 0.75. What is the ratio of the Cost of communications, computer etc. (% of service imports) of Brazil in 2007 to that in 2012?
Keep it short and to the point. 0.97. What is the ratio of the Cost of communications, computer etc. (% of service imports) in Netherlands in 2007 to that in 2012?
Your answer should be very brief. 1.01. What is the ratio of the Cost of communications, computer etc. (% of service imports) of Benin in 2008 to that in 2009?
Provide a short and direct response. 0.84. What is the ratio of the Cost of communications, computer etc. (% of service imports) of Brazil in 2008 to that in 2009?
Offer a terse response. 0.93. What is the ratio of the Cost of communications, computer etc. (% of service imports) in Benin in 2008 to that in 2010?
Your answer should be very brief. 0.93. What is the ratio of the Cost of communications, computer etc. (% of service imports) of Brazil in 2008 to that in 2010?
Keep it short and to the point. 0.97. What is the ratio of the Cost of communications, computer etc. (% of service imports) in Netherlands in 2008 to that in 2010?
Your response must be concise. 1.02. What is the ratio of the Cost of communications, computer etc. (% of service imports) in Brazil in 2008 to that in 2011?
Offer a very short reply. 1. What is the ratio of the Cost of communications, computer etc. (% of service imports) of Benin in 2008 to that in 2012?
Offer a terse response. 0.97. What is the ratio of the Cost of communications, computer etc. (% of service imports) in Brazil in 2008 to that in 2012?
Provide a succinct answer. 0.96. What is the ratio of the Cost of communications, computer etc. (% of service imports) in Netherlands in 2008 to that in 2012?
Provide a succinct answer. 1.01. What is the ratio of the Cost of communications, computer etc. (% of service imports) of Benin in 2009 to that in 2010?
Keep it short and to the point. 1.1. What is the ratio of the Cost of communications, computer etc. (% of service imports) of Brazil in 2009 to that in 2010?
Provide a short and direct response. 1.04. What is the ratio of the Cost of communications, computer etc. (% of service imports) in Netherlands in 2009 to that in 2010?
Ensure brevity in your answer.  1.02. What is the ratio of the Cost of communications, computer etc. (% of service imports) of Benin in 2009 to that in 2011?
Your response must be concise. 1.19. What is the ratio of the Cost of communications, computer etc. (% of service imports) in Brazil in 2009 to that in 2011?
Your answer should be very brief. 1.08. What is the ratio of the Cost of communications, computer etc. (% of service imports) in Benin in 2009 to that in 2012?
Provide a succinct answer. 1.15. What is the ratio of the Cost of communications, computer etc. (% of service imports) in Brazil in 2009 to that in 2012?
Your answer should be very brief. 1.04. What is the ratio of the Cost of communications, computer etc. (% of service imports) in Netherlands in 2009 to that in 2012?
Give a very brief answer. 1.01. What is the ratio of the Cost of communications, computer etc. (% of service imports) in Benin in 2010 to that in 2011?
Your response must be concise. 1.08. What is the ratio of the Cost of communications, computer etc. (% of service imports) in Brazil in 2010 to that in 2011?
Your answer should be very brief. 1.03. What is the ratio of the Cost of communications, computer etc. (% of service imports) in Netherlands in 2010 to that in 2011?
Ensure brevity in your answer.  0.98. What is the ratio of the Cost of communications, computer etc. (% of service imports) of Benin in 2010 to that in 2012?
Your response must be concise. 1.04. What is the ratio of the Cost of communications, computer etc. (% of service imports) of Brazil in 2010 to that in 2012?
Provide a short and direct response. 0.99. What is the ratio of the Cost of communications, computer etc. (% of service imports) in Netherlands in 2010 to that in 2012?
Provide a succinct answer. 0.98. What is the ratio of the Cost of communications, computer etc. (% of service imports) of Benin in 2011 to that in 2012?
Offer a very short reply. 0.97. What is the ratio of the Cost of communications, computer etc. (% of service imports) in Brazil in 2011 to that in 2012?
Keep it short and to the point. 0.96. What is the ratio of the Cost of communications, computer etc. (% of service imports) of Netherlands in 2011 to that in 2012?
Provide a short and direct response. 1. What is the difference between the highest and the second highest Cost of communications, computer etc. (% of service imports) in Benin?
Provide a succinct answer. 2.47. What is the difference between the highest and the second highest Cost of communications, computer etc. (% of service imports) of Brazil?
Provide a short and direct response. 0.48. What is the difference between the highest and the second highest Cost of communications, computer etc. (% of service imports) in Netherlands?
Offer a terse response. 0.06. What is the difference between the highest and the lowest Cost of communications, computer etc. (% of service imports) in Benin?
Provide a short and direct response. 9.13. What is the difference between the highest and the lowest Cost of communications, computer etc. (% of service imports) in Brazil?
Keep it short and to the point. 3.84. What is the difference between the highest and the lowest Cost of communications, computer etc. (% of service imports) in Netherlands?
Provide a succinct answer. 1.67. 